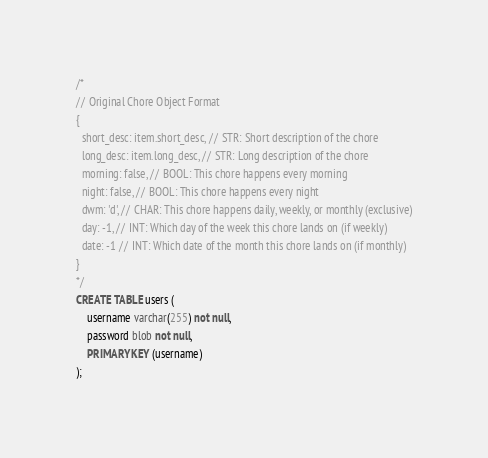<code> <loc_0><loc_0><loc_500><loc_500><_SQL_>/*
// Original Chore Object Format
{
  short_desc: item.short_desc, // STR: Short description of the chore
  long_desc: item.long_desc, // STR: Long description of the chore
  morning: false, // BOOL: This chore happens every morning
  night: false, // BOOL: This chore happens every night
  dwm: 'd', // CHAR: This chore happens daily, weekly, or monthly (exclusive)
  day: -1, // INT: Which day of the week this chore lands on (if weekly)
  date: -1 // INT: Which date of the month this chore lands on (if monthly)
}
*/
CREATE TABLE users (
    username varchar(255) not null,
    password blob not null,
    PRIMARY KEY (username)
);
</code> 